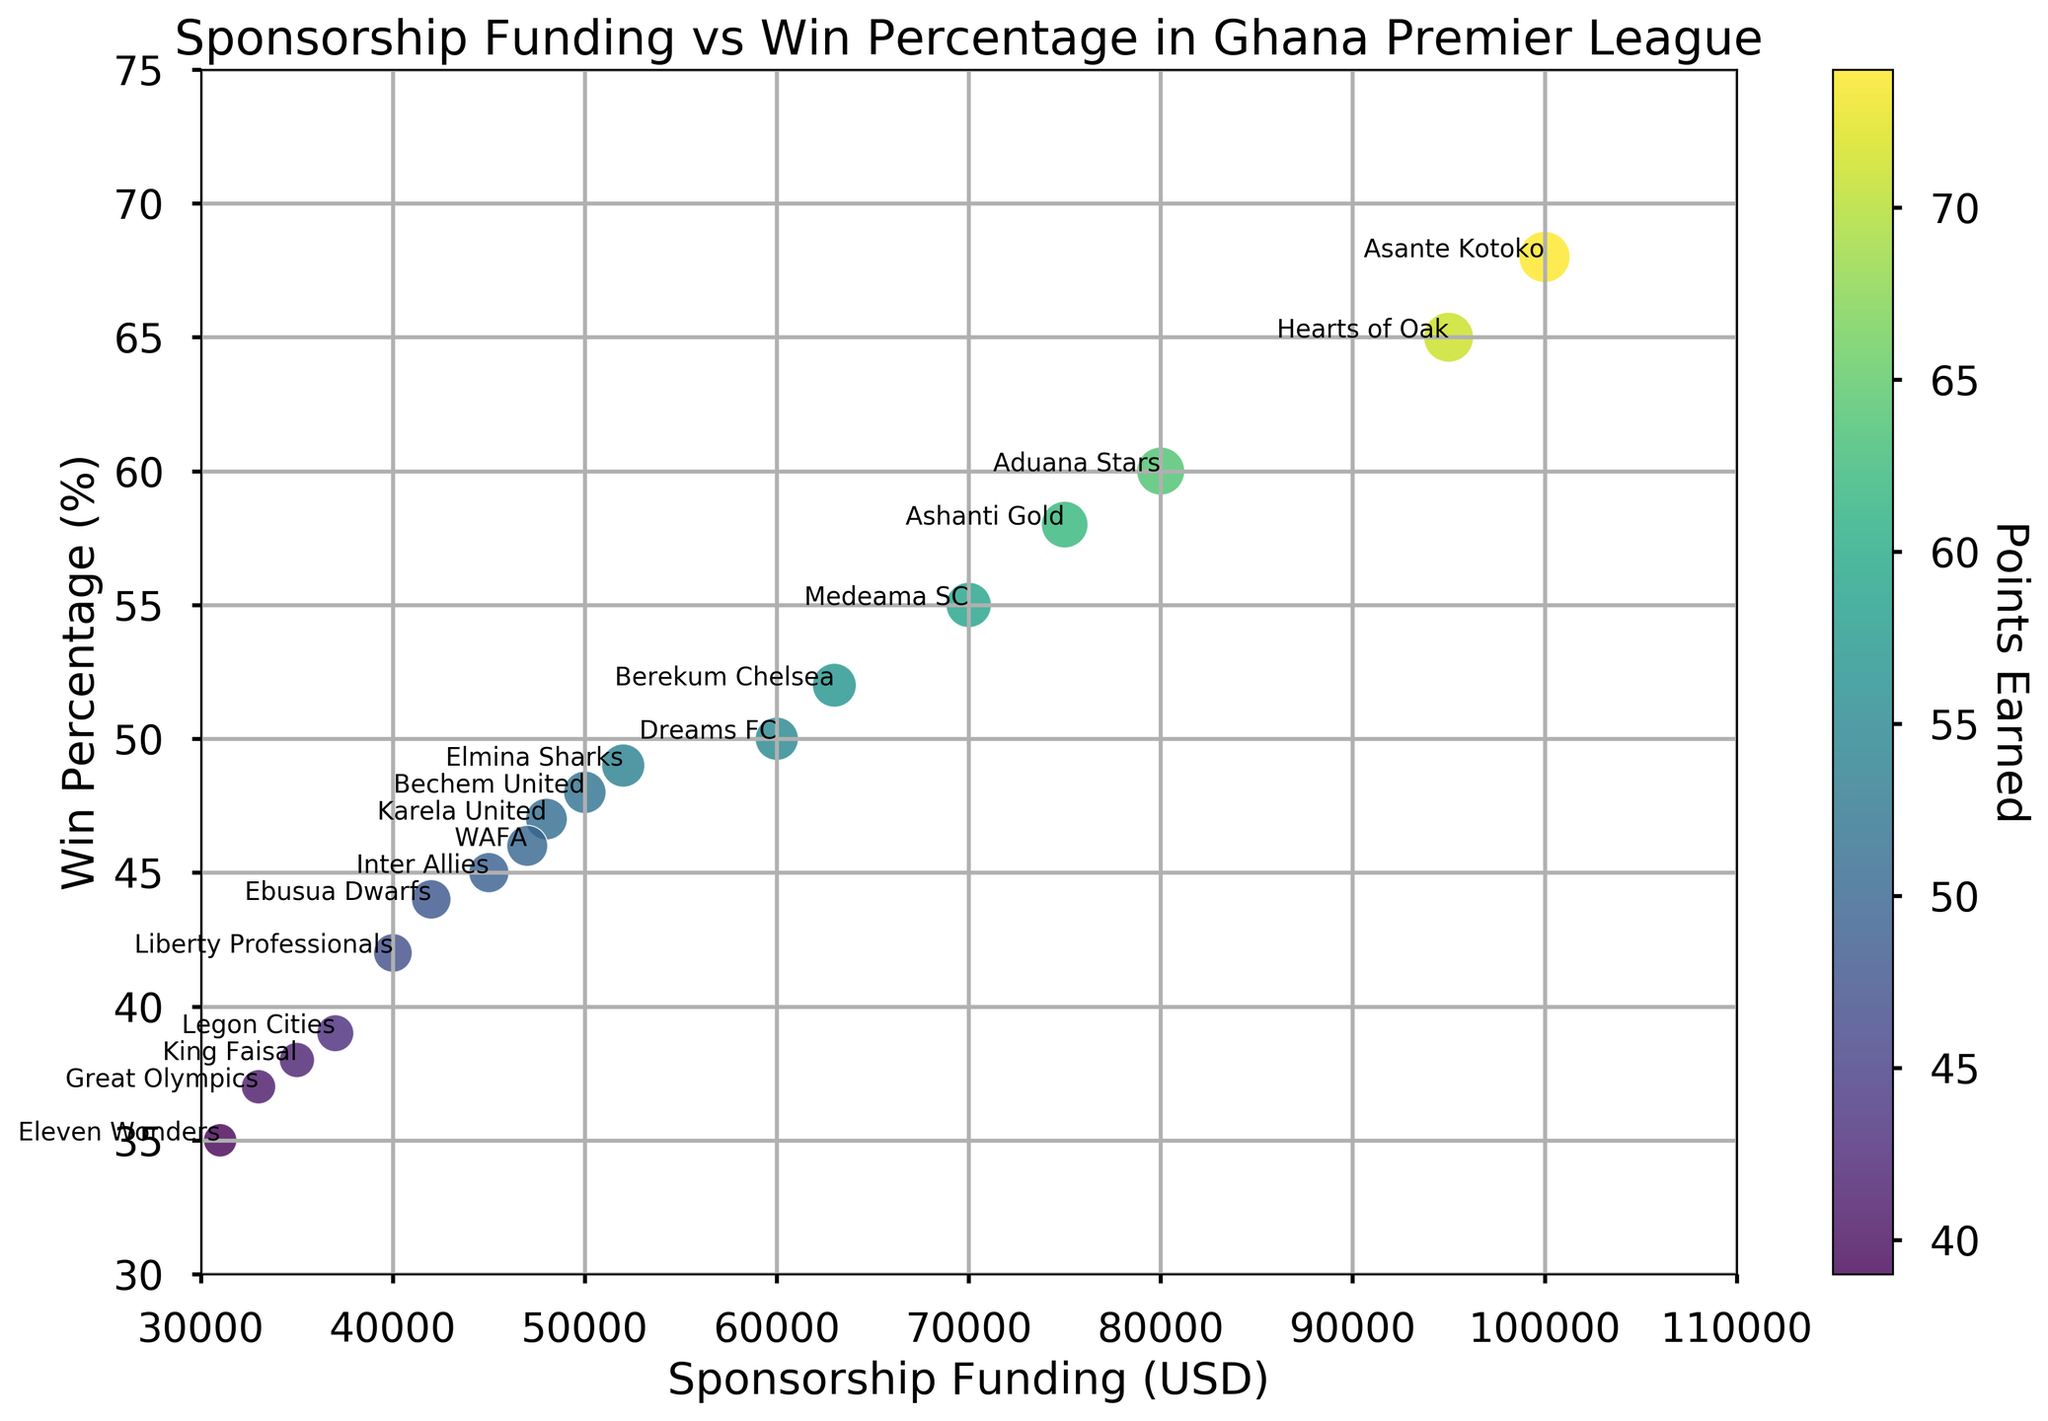Which team has the highest sponsorship funding? Looking at the x-axis for Sponsorship Funding, the highest point corresponds to Asante Kotoko.
Answer: Asante Kotoko Which team scored the most goals? The marker size represents Goals Scored, and the largest marker size corresponds to Asante Kotoko.
Answer: Asante Kotoko How does the win percentage of Hearts of Oak compare to Dreams FC? Hearts of Oak is at 65% on the y-axis, while Dreams FC is at 50% on the y-axis.
Answer: Hearts of Oak has a higher win percentage Which team has the least points earned? By examining the color intensity, the team with the darkest marker, indicating the fewest points, is Eleven Wonders.
Answer: Eleven Wonders What is the average win percentage of teams with sponsorship funding above $70,000? Teams above $70,000 are Asante Kotoko (68%), Hearts of Oak (65%), Ashanti Gold (58%), and Aduana Stars (60%). The average is (68 + 65 + 58 + 60) / 4 = 62.75%.
Answer: 62.75% Does sponsorship funding correlate positively with win percentage? Observing the scatter plot trend from lower left to upper right indicates that, generally, higher sponsorship funding is associated with higher win percentages.
Answer: Yes Between Bechem United and Karela United, which team has scored more goals? Marker size represents Goals Scored. Bechem United has a slightly larger marker size than Karela United.
Answer: Bechem United What is the difference in points earned between King Faisal and Great Olympics? King Faisal has 42 points, and Great Olympics has 41 points. The difference is 42 - 41 = 1.
Answer: 1 Which team with sponsorship funding below $50,000 has the highest win percentage? Filter teams with funding below $50,000, then find the highest y-axis value. Ebusua Dwarfs at 44% stands out.
Answer: Ebusua Dwarfs What is the range of win percentages for all teams? The minimum win percentage is 35% (Eleven Wonders), and the maximum is 68% (Asante Kotoko). The range is 68 - 35 = 33.
Answer: 33 